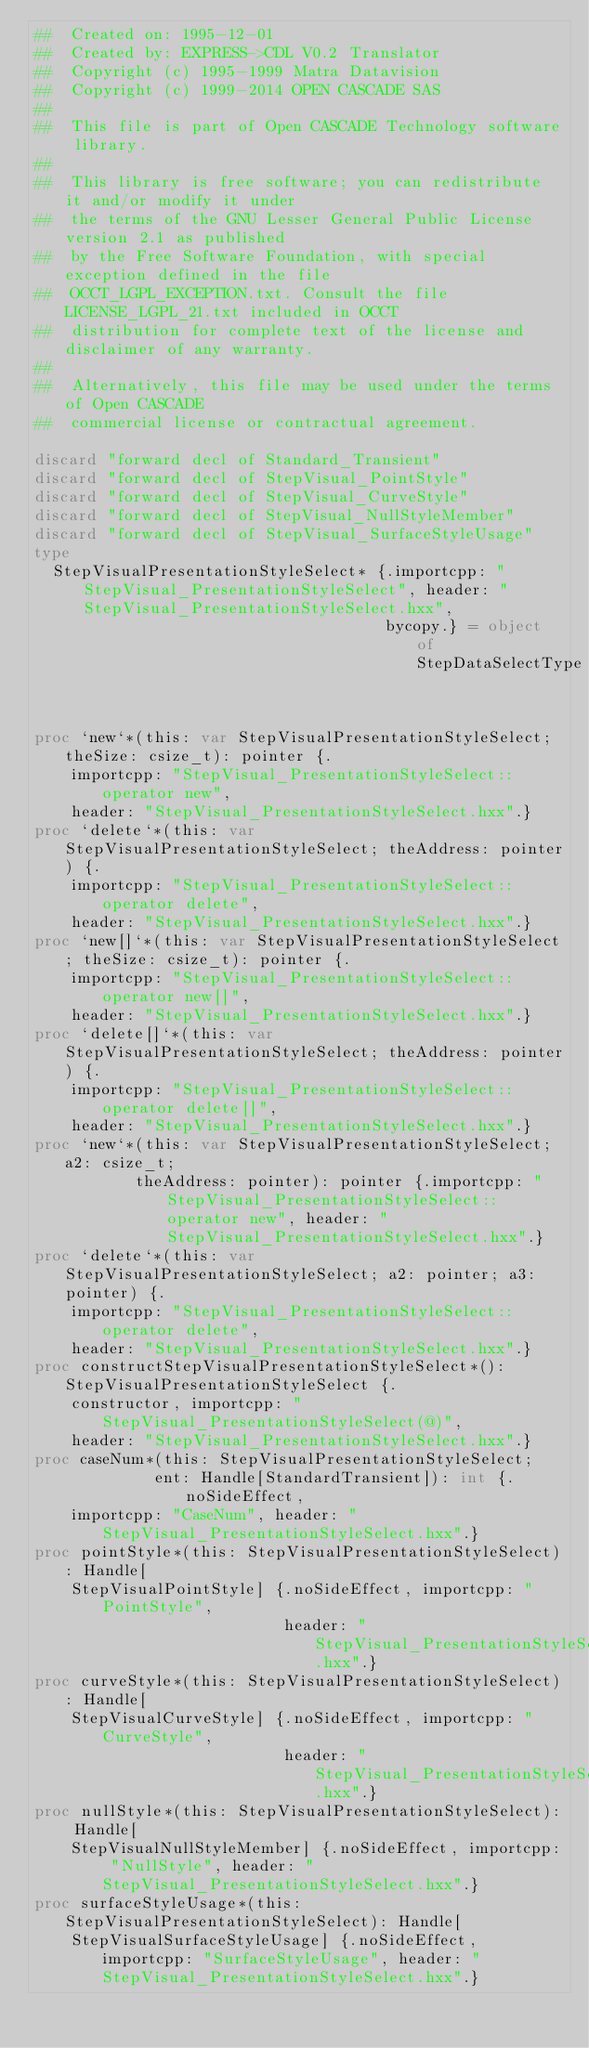<code> <loc_0><loc_0><loc_500><loc_500><_Nim_>##  Created on: 1995-12-01
##  Created by: EXPRESS->CDL V0.2 Translator
##  Copyright (c) 1995-1999 Matra Datavision
##  Copyright (c) 1999-2014 OPEN CASCADE SAS
##
##  This file is part of Open CASCADE Technology software library.
##
##  This library is free software; you can redistribute it and/or modify it under
##  the terms of the GNU Lesser General Public License version 2.1 as published
##  by the Free Software Foundation, with special exception defined in the file
##  OCCT_LGPL_EXCEPTION.txt. Consult the file LICENSE_LGPL_21.txt included in OCCT
##  distribution for complete text of the license and disclaimer of any warranty.
##
##  Alternatively, this file may be used under the terms of Open CASCADE
##  commercial license or contractual agreement.

discard "forward decl of Standard_Transient"
discard "forward decl of StepVisual_PointStyle"
discard "forward decl of StepVisual_CurveStyle"
discard "forward decl of StepVisual_NullStyleMember"
discard "forward decl of StepVisual_SurfaceStyleUsage"
type
  StepVisualPresentationStyleSelect* {.importcpp: "StepVisual_PresentationStyleSelect", header: "StepVisual_PresentationStyleSelect.hxx",
                                      bycopy.} = object of StepDataSelectType


proc `new`*(this: var StepVisualPresentationStyleSelect; theSize: csize_t): pointer {.
    importcpp: "StepVisual_PresentationStyleSelect::operator new",
    header: "StepVisual_PresentationStyleSelect.hxx".}
proc `delete`*(this: var StepVisualPresentationStyleSelect; theAddress: pointer) {.
    importcpp: "StepVisual_PresentationStyleSelect::operator delete",
    header: "StepVisual_PresentationStyleSelect.hxx".}
proc `new[]`*(this: var StepVisualPresentationStyleSelect; theSize: csize_t): pointer {.
    importcpp: "StepVisual_PresentationStyleSelect::operator new[]",
    header: "StepVisual_PresentationStyleSelect.hxx".}
proc `delete[]`*(this: var StepVisualPresentationStyleSelect; theAddress: pointer) {.
    importcpp: "StepVisual_PresentationStyleSelect::operator delete[]",
    header: "StepVisual_PresentationStyleSelect.hxx".}
proc `new`*(this: var StepVisualPresentationStyleSelect; a2: csize_t;
           theAddress: pointer): pointer {.importcpp: "StepVisual_PresentationStyleSelect::operator new", header: "StepVisual_PresentationStyleSelect.hxx".}
proc `delete`*(this: var StepVisualPresentationStyleSelect; a2: pointer; a3: pointer) {.
    importcpp: "StepVisual_PresentationStyleSelect::operator delete",
    header: "StepVisual_PresentationStyleSelect.hxx".}
proc constructStepVisualPresentationStyleSelect*(): StepVisualPresentationStyleSelect {.
    constructor, importcpp: "StepVisual_PresentationStyleSelect(@)",
    header: "StepVisual_PresentationStyleSelect.hxx".}
proc caseNum*(this: StepVisualPresentationStyleSelect;
             ent: Handle[StandardTransient]): int {.noSideEffect,
    importcpp: "CaseNum", header: "StepVisual_PresentationStyleSelect.hxx".}
proc pointStyle*(this: StepVisualPresentationStyleSelect): Handle[
    StepVisualPointStyle] {.noSideEffect, importcpp: "PointStyle",
                           header: "StepVisual_PresentationStyleSelect.hxx".}
proc curveStyle*(this: StepVisualPresentationStyleSelect): Handle[
    StepVisualCurveStyle] {.noSideEffect, importcpp: "CurveStyle",
                           header: "StepVisual_PresentationStyleSelect.hxx".}
proc nullStyle*(this: StepVisualPresentationStyleSelect): Handle[
    StepVisualNullStyleMember] {.noSideEffect, importcpp: "NullStyle", header: "StepVisual_PresentationStyleSelect.hxx".}
proc surfaceStyleUsage*(this: StepVisualPresentationStyleSelect): Handle[
    StepVisualSurfaceStyleUsage] {.noSideEffect, importcpp: "SurfaceStyleUsage", header: "StepVisual_PresentationStyleSelect.hxx".}</code> 